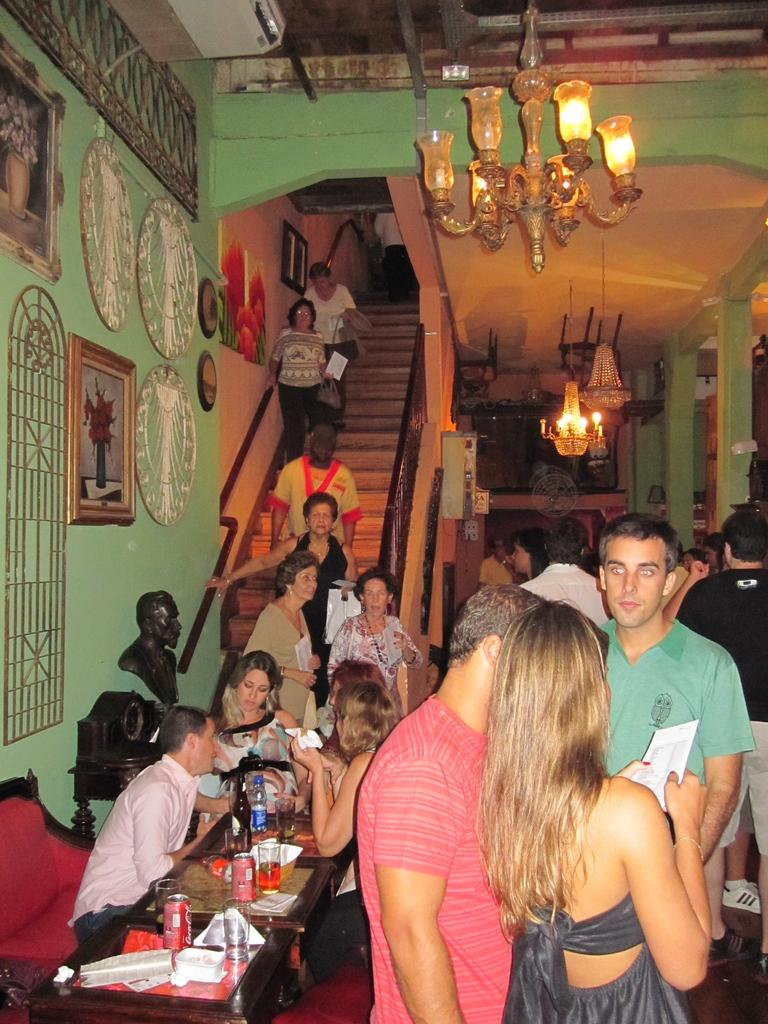How many people are in the room? There are people in the room, but the exact number is not specified. What are some people doing in the room? Some people are coming down the stairs. What is hanging from the ceiling in the room? There is a chandelier hanging in the room. What type of decorations can be seen on the wall? There are frames on the wall. Who is the expert on the wrist in the image? There is no mention of an expert or a wrist in the image. 